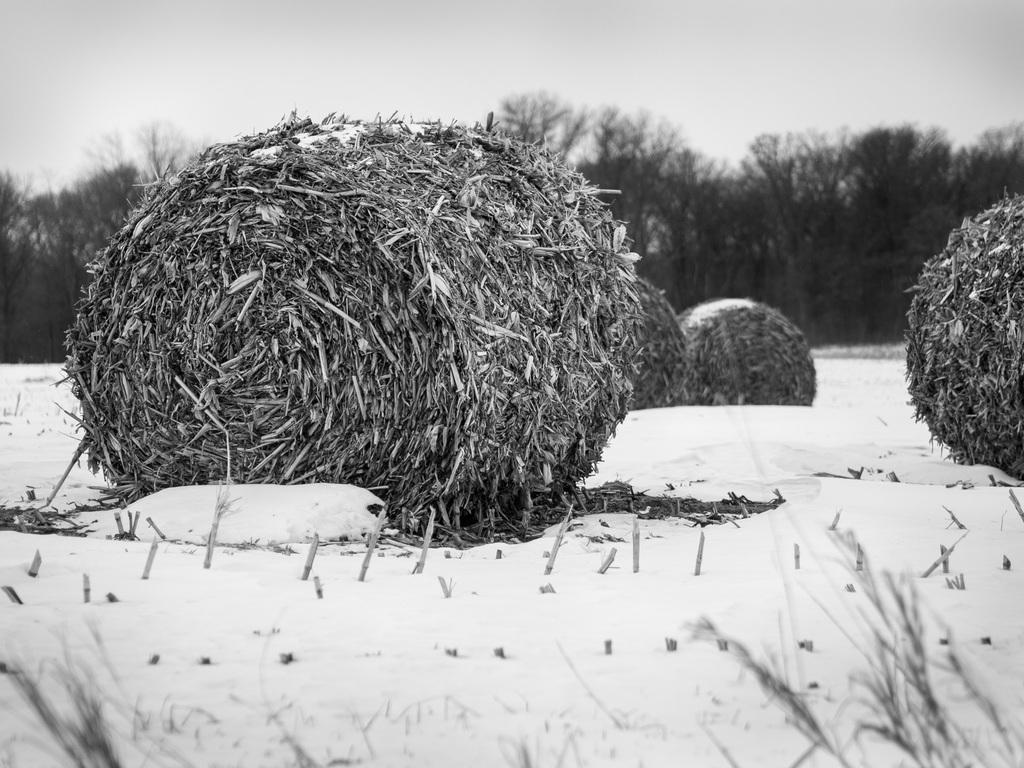What is the color scheme of the image? The image is black and white. What objects are present in the foreground of the image? There are dried grass rolls in the image. What can be seen in the background of the image? There are trees in the background of the image. What is visible in the sky in the image? The sky is visible in the image. What might be the weather condition in the image? The image appears to depict snow. What type of property does the son inherit in the image? There is no reference to a property or a son in the image, so it is not possible to answer that question. 